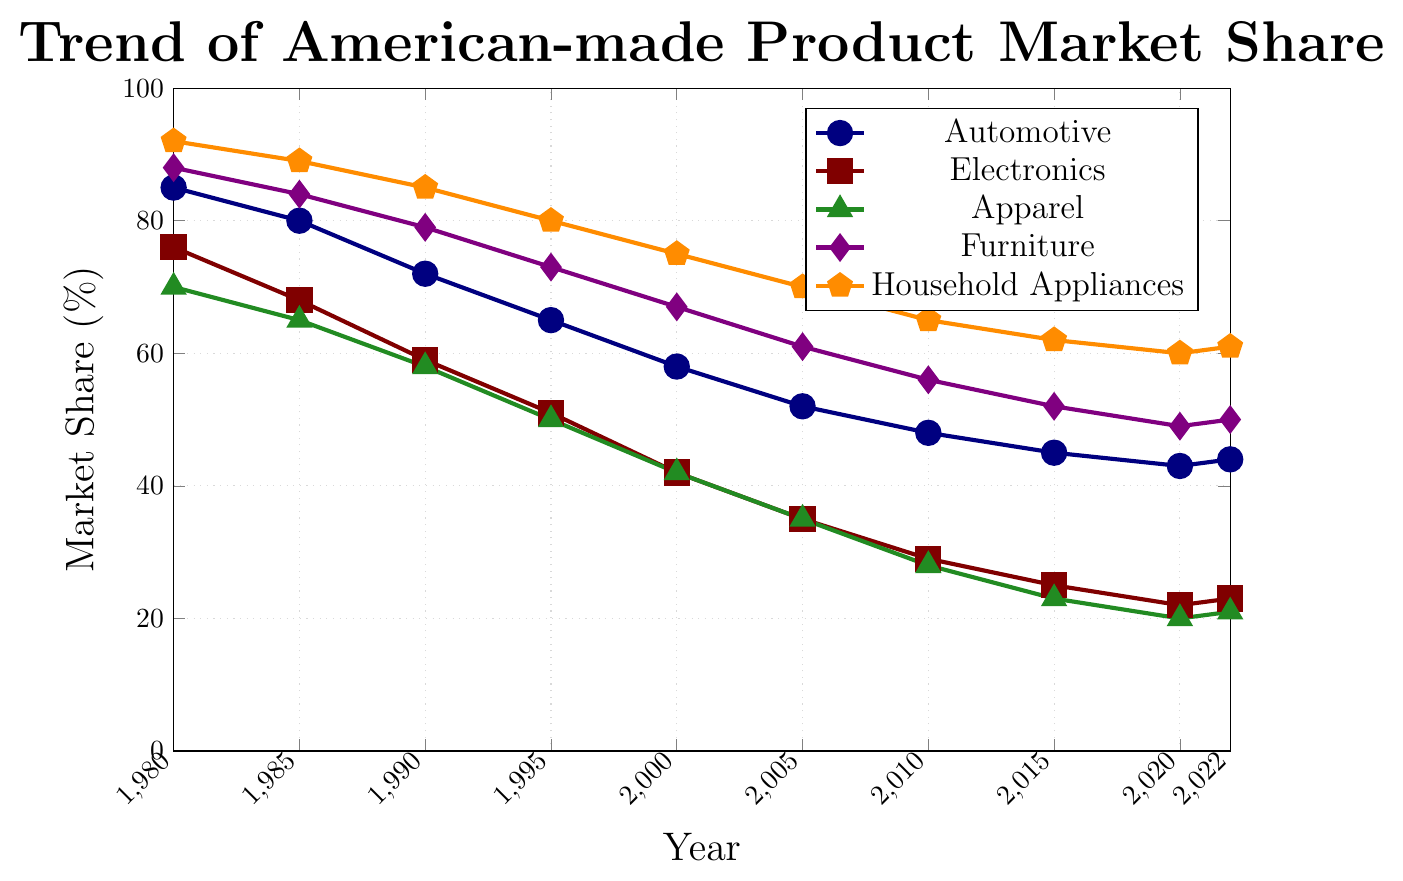What's the market share of American-made household appliances in 1990? The household appliances market share is represented by the orange line. In 1990, the market share for household appliances is at 85%.
Answer: 85% How did the market share of American-made electronics change from 1980 to 2020? To find the change, observe the maroon line for electronics. In 1980, the market share is 76%, and in 2020, it is 22%. The change in market share is 76% - 22% = 54%.
Answer: Decreased by 54% Which industry has the least decline in market share from 1980 to 2022? Calculate the decline for each industry by subtracting the 2022 value from the 1980 value: 
Automotive: 85% - 44% = 41%, Electronics: 76% - 23% = 53%, Apparel: 70% - 21% = 49%, Furniture: 88% - 50% = 38%, Household Appliances: 92% - 61% = 31%. The least decline is for Household Appliances at 31%.
Answer: Household Appliances What is the difference in market share between American-made automotive products and apparel in 2020? Look at the values for 2020: Automotive is 43%, and Apparel is 20%. The difference is 43% - 20% = 23%.
Answer: 23% Which industry had the highest market share in 1985 and what was it? In 1985, observe the highest point across all industries. The household appliances line (orange) is highest at 89%.
Answer: Household Appliances, 89% From 2005 to 2022, which industry showed an increase in market share? Observe the trend lines from 2005 to 2022. The only line that shows an increase from 2005 (61%) to 2022 (50%) is Furniture (purple).
Answer: Furniture In which year was the market share of American-made electronics closest to that of American-made apparel? Compare the maroon and forest green lines for each year. They are closest in 2010, with electronics at 29% and apparel at 28%.
Answer: 2010 Calculate the average market share of American-made furniture from 1980 to 2022. Sum up the values for furniture: 88 + 84 + 79 + 73 + 67 + 61 + 56 + 52 + 49 + 50 = 659. The average is 659/10 = 65.9%.
Answer: 65.9% Which industry experienced the steepest decline in market share between 1980 and 1995? Calculate the decline for each industry from 1980 to 1995: 
Automotive: 85% - 65% = 20%, Electronics: 76% - 51% = 25%, Apparel: 70% - 50% = 20%, Furniture: 88% - 73% = 15%, Household Appliances: 92% - 80% = 12%. The steepest decline is for Electronics at 25%.
Answer: Electronics What is the trend of the automotive industry market share from 1980 to 2022? Observe the navy line from 1980 to 2022. The market share shows a general declining trend: from 85% in 1980 to 44% in 2022.
Answer: Declining 